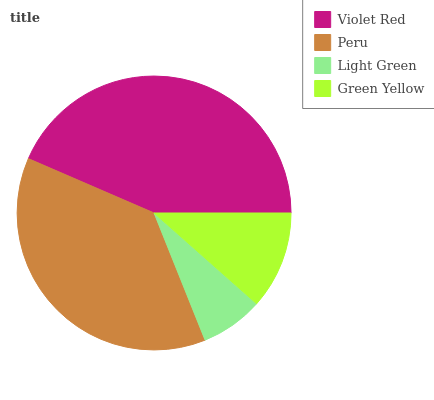Is Light Green the minimum?
Answer yes or no. Yes. Is Violet Red the maximum?
Answer yes or no. Yes. Is Peru the minimum?
Answer yes or no. No. Is Peru the maximum?
Answer yes or no. No. Is Violet Red greater than Peru?
Answer yes or no. Yes. Is Peru less than Violet Red?
Answer yes or no. Yes. Is Peru greater than Violet Red?
Answer yes or no. No. Is Violet Red less than Peru?
Answer yes or no. No. Is Peru the high median?
Answer yes or no. Yes. Is Green Yellow the low median?
Answer yes or no. Yes. Is Light Green the high median?
Answer yes or no. No. Is Light Green the low median?
Answer yes or no. No. 